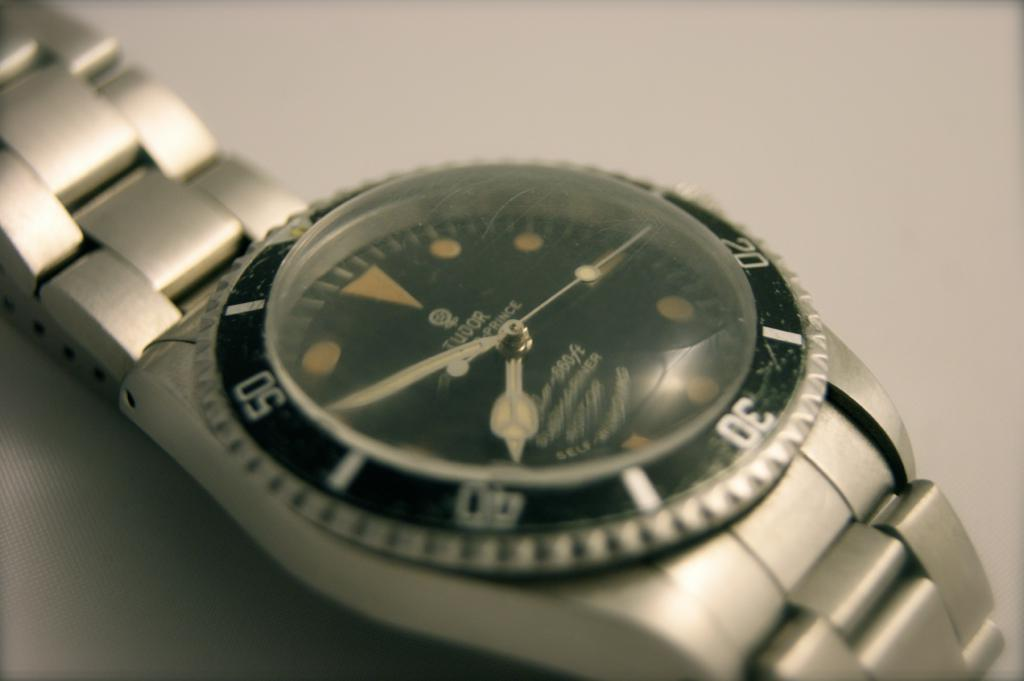Provide a one-sentence caption for the provided image. A Tudor brand silver wrist watch is self winding. 